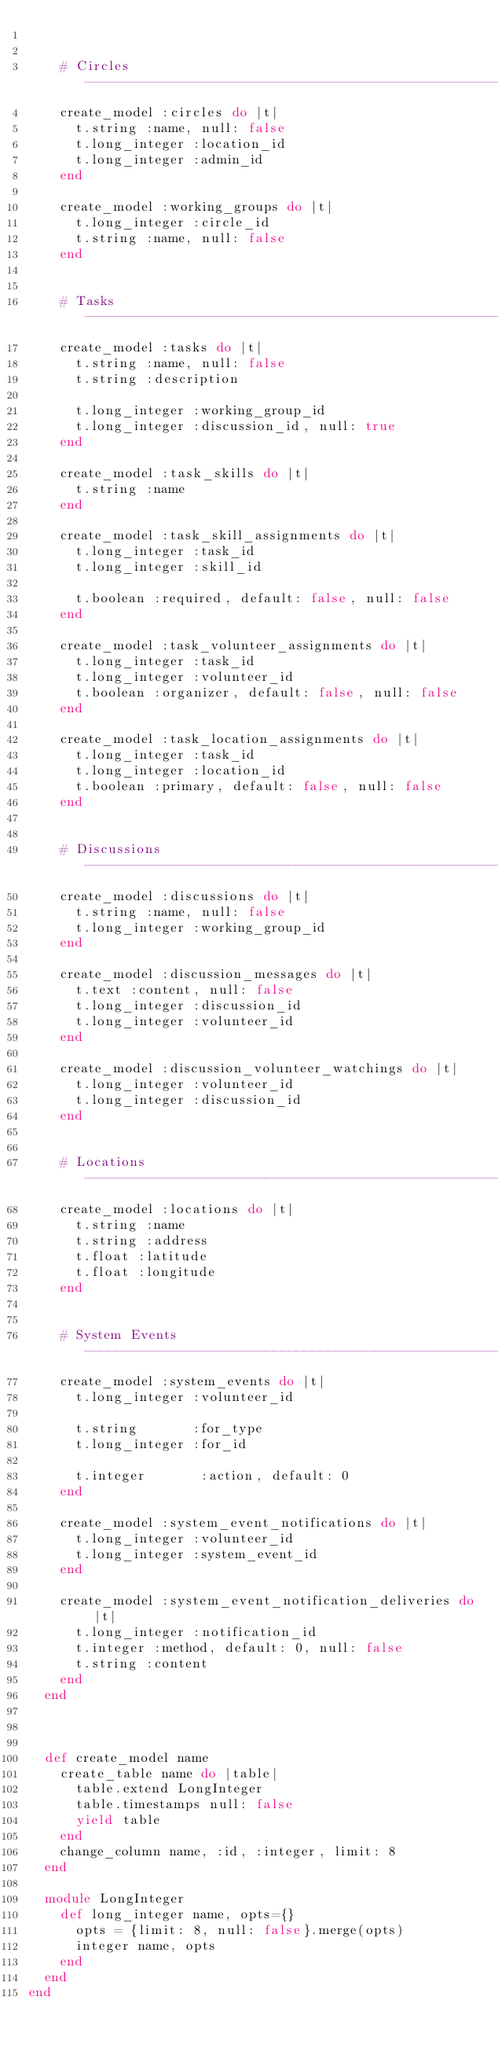<code> <loc_0><loc_0><loc_500><loc_500><_Ruby_>

    # Circles -----------------------------------------------------------------
    create_model :circles do |t|
      t.string :name, null: false
      t.long_integer :location_id
      t.long_integer :admin_id
    end

    create_model :working_groups do |t|
      t.long_integer :circle_id
      t.string :name, null: false
    end


    # Tasks -------------------------------------------------------------------
    create_model :tasks do |t|
      t.string :name, null: false
      t.string :description

      t.long_integer :working_group_id
      t.long_integer :discussion_id, null: true
    end

    create_model :task_skills do |t|
      t.string :name
    end

    create_model :task_skill_assignments do |t|
      t.long_integer :task_id
      t.long_integer :skill_id

      t.boolean :required, default: false, null: false
    end

    create_model :task_volunteer_assignments do |t|
      t.long_integer :task_id
      t.long_integer :volunteer_id
      t.boolean :organizer, default: false, null: false
    end

    create_model :task_location_assignments do |t|
      t.long_integer :task_id
      t.long_integer :location_id
      t.boolean :primary, default: false, null: false
    end


    # Discussions -------------------------------------------------------------
    create_model :discussions do |t|
      t.string :name, null: false
      t.long_integer :working_group_id
    end

    create_model :discussion_messages do |t|
      t.text :content, null: false
      t.long_integer :discussion_id
      t.long_integer :volunteer_id
    end

    create_model :discussion_volunteer_watchings do |t|
      t.long_integer :volunteer_id
      t.long_integer :discussion_id
    end


    # Locations ---------------------------------------------------------------
    create_model :locations do |t|
      t.string :name
      t.string :address
      t.float :latitude
      t.float :longitude
    end


    # System Events -----------------------------------------------------------
    create_model :system_events do |t|
      t.long_integer :volunteer_id

      t.string       :for_type
      t.long_integer :for_id

      t.integer       :action, default: 0
    end

    create_model :system_event_notifications do |t|
      t.long_integer :volunteer_id
      t.long_integer :system_event_id
    end

    create_model :system_event_notification_deliveries do |t|
      t.long_integer :notification_id
      t.integer :method, default: 0, null: false
      t.string :content
    end
  end



  def create_model name
    create_table name do |table|
      table.extend LongInteger
      table.timestamps null: false
      yield table
    end
    change_column name, :id, :integer, limit: 8
  end

  module LongInteger
    def long_integer name, opts={}
      opts = {limit: 8, null: false}.merge(opts)
      integer name, opts
    end
  end
end
</code> 